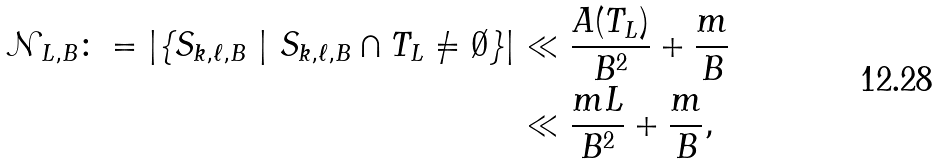<formula> <loc_0><loc_0><loc_500><loc_500>\mathcal { N } _ { L , B } \colon = | \{ S _ { k , \ell , B } \ | \ S _ { k , \ell , B } \cap T _ { L } \neq \emptyset \} | & \ll \frac { A ( T _ { L } ) } { B ^ { 2 } } + \frac { m } { B } \\ & \ll \frac { m L } { B ^ { 2 } } + \frac { m } { B } ,</formula> 